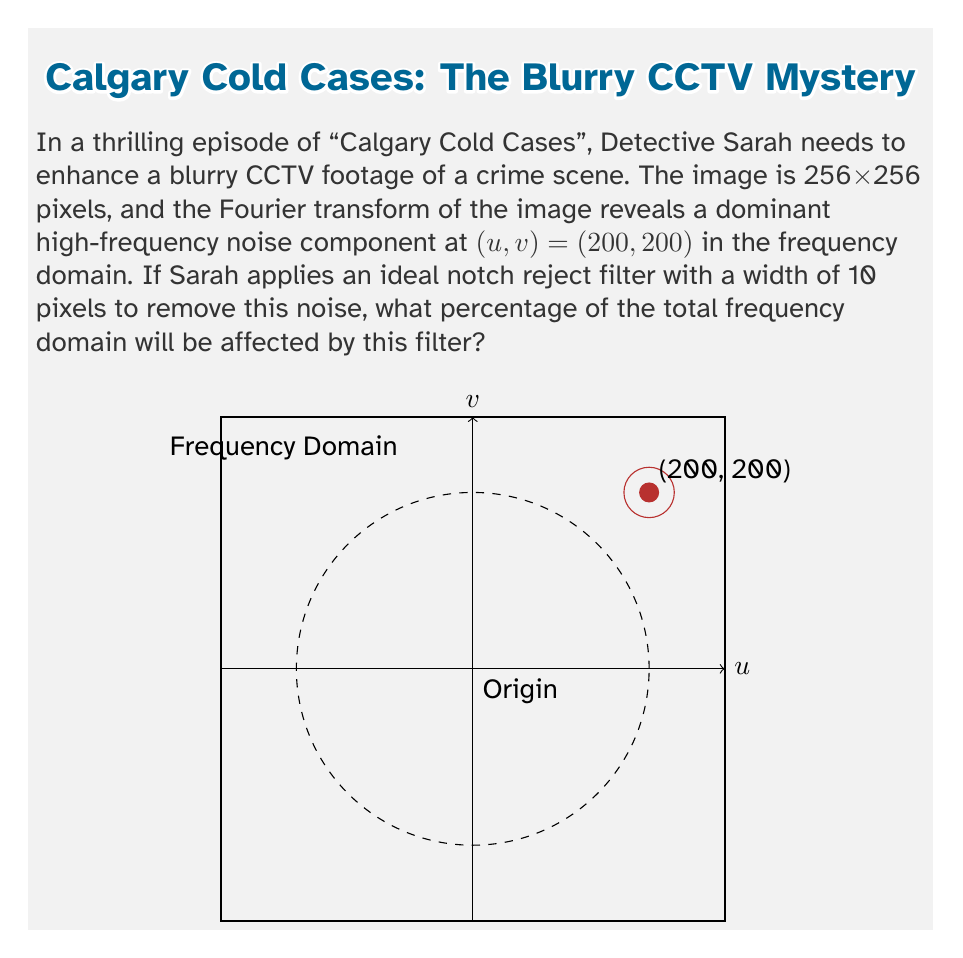Can you solve this math problem? Let's approach this step-by-step:

1) The Fourier transform of a 256x256 image results in a 256x256 frequency domain.

2) The total area of the frequency domain is:
   $$A_{total} = 256 \times 256 = 65,536$$ pixels

3) The notch reject filter is centered at (200, 200) with a width of 10 pixels. This forms a circular area in the frequency domain.

4) The area of this circular filter is:
   $$A_{filter} = \pi r^2 = \pi (5)^2 = 25\pi$$ pixels
   (radius is half the width)

5) However, in the Fourier transform, there's symmetry around the origin. So we need to consider the filter's effect at (-200, -200) as well. This doubles the affected area:
   $$A_{affected} = 2 \times 25\pi = 50\pi$$ pixels

6) To calculate the percentage, we divide the affected area by the total area and multiply by 100:
   $$Percentage = \frac{A_{affected}}{A_{total}} \times 100 = \frac{50\pi}{65,536} \times 100 \approx 0.2395\%$$
Answer: 0.2395% 